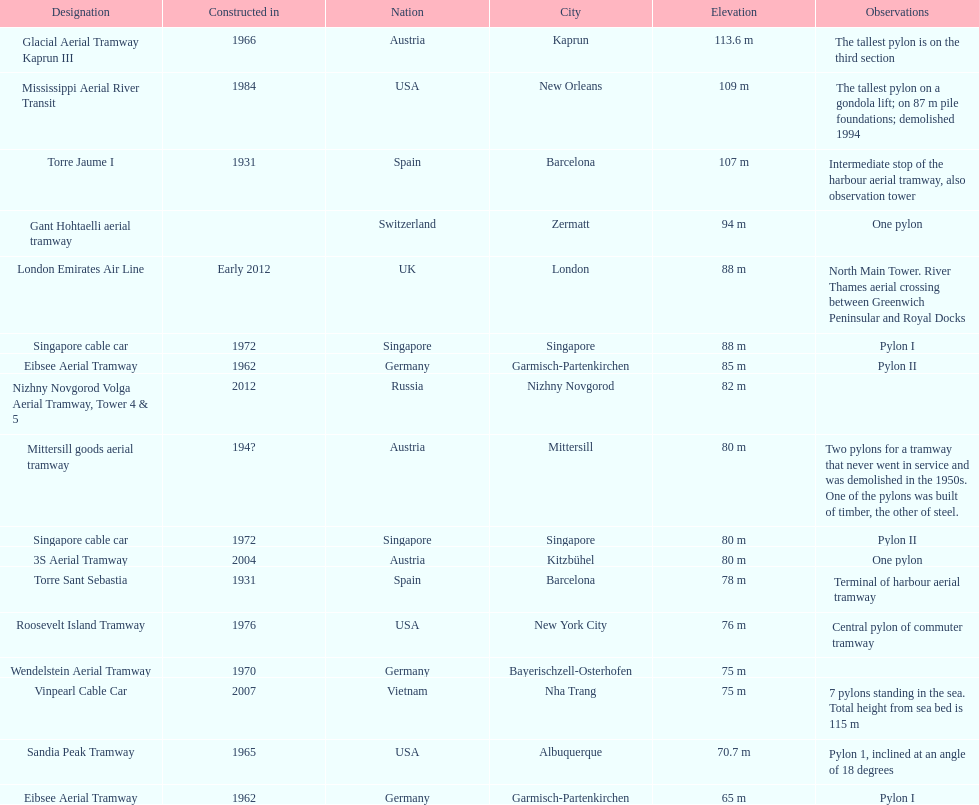What is the total number of tallest pylons in austria? 3. 